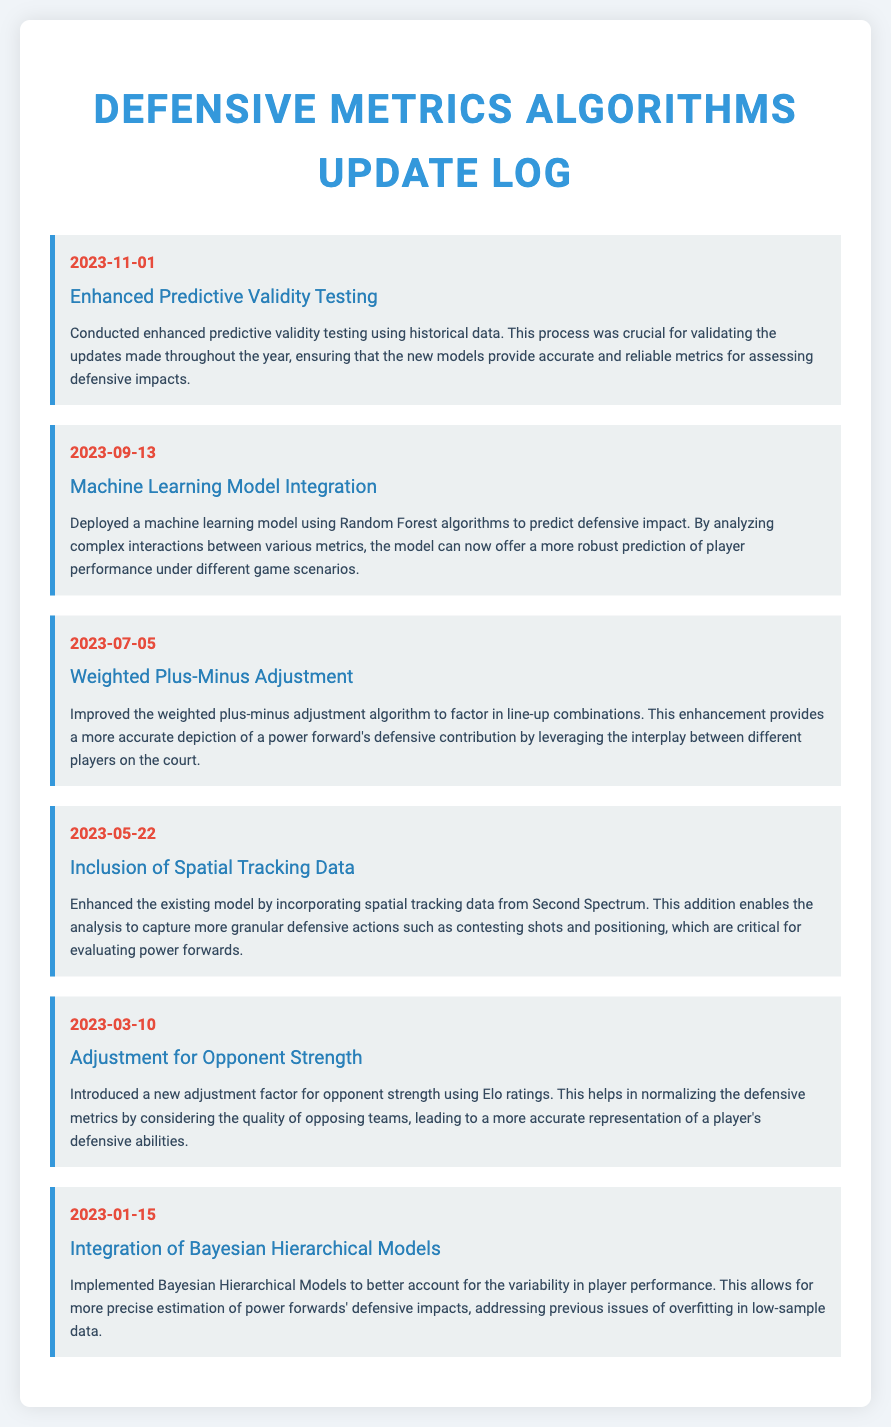What is the date of the latest log entry? The latest log entry is dated November 1, 2023.
Answer: November 1, 2023 What was improved on July 5, 2023? On July 5, 2023, the weighted plus-minus adjustment algorithm was improved.
Answer: Weighted Plus-Minus Adjustment What is the title of the log entry on September 13, 2023? The title of the log entry on September 13, 2023, is "Machine Learning Model Integration."
Answer: Machine Learning Model Integration What new data source was incorporated on May 22, 2023? Spatial tracking data from Second Spectrum was incorporated on May 22, 2023.
Answer: Spatial tracking data What is the purpose of the Bayesian Hierarchical Models implemented on January 15, 2023? The purpose is to better account for the variability in player performance.
Answer: Variability in player performance What adjustment factor was introduced on March 10, 2023? A new adjustment factor for opponent strength using Elo ratings was introduced.
Answer: Opponent strength What statistical method was deployed to predict defensive impact? A machine learning model using Random Forest algorithms was deployed.
Answer: Random Forest algorithms 